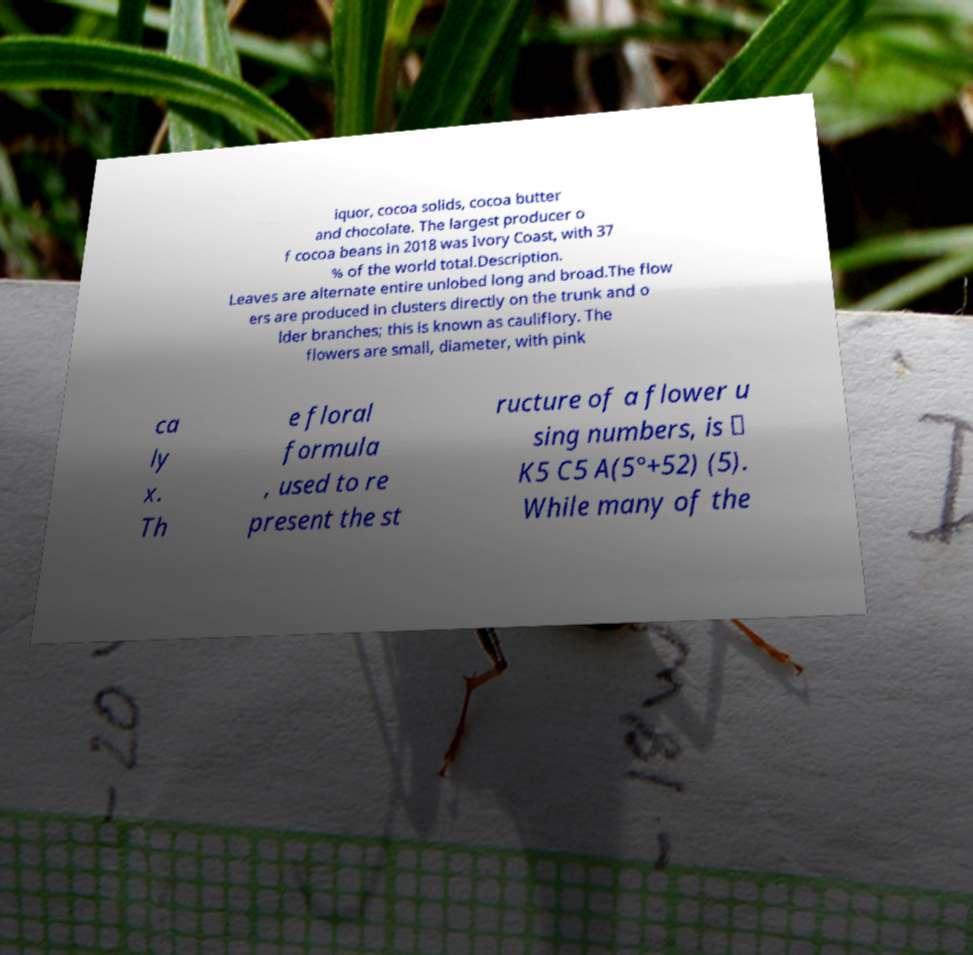Could you assist in decoding the text presented in this image and type it out clearly? iquor, cocoa solids, cocoa butter and chocolate. The largest producer o f cocoa beans in 2018 was Ivory Coast, with 37 % of the world total.Description. Leaves are alternate entire unlobed long and broad.The flow ers are produced in clusters directly on the trunk and o lder branches; this is known as cauliflory. The flowers are small, diameter, with pink ca ly x. Th e floral formula , used to re present the st ructure of a flower u sing numbers, is ✶ K5 C5 A(5°+52) (5). While many of the 